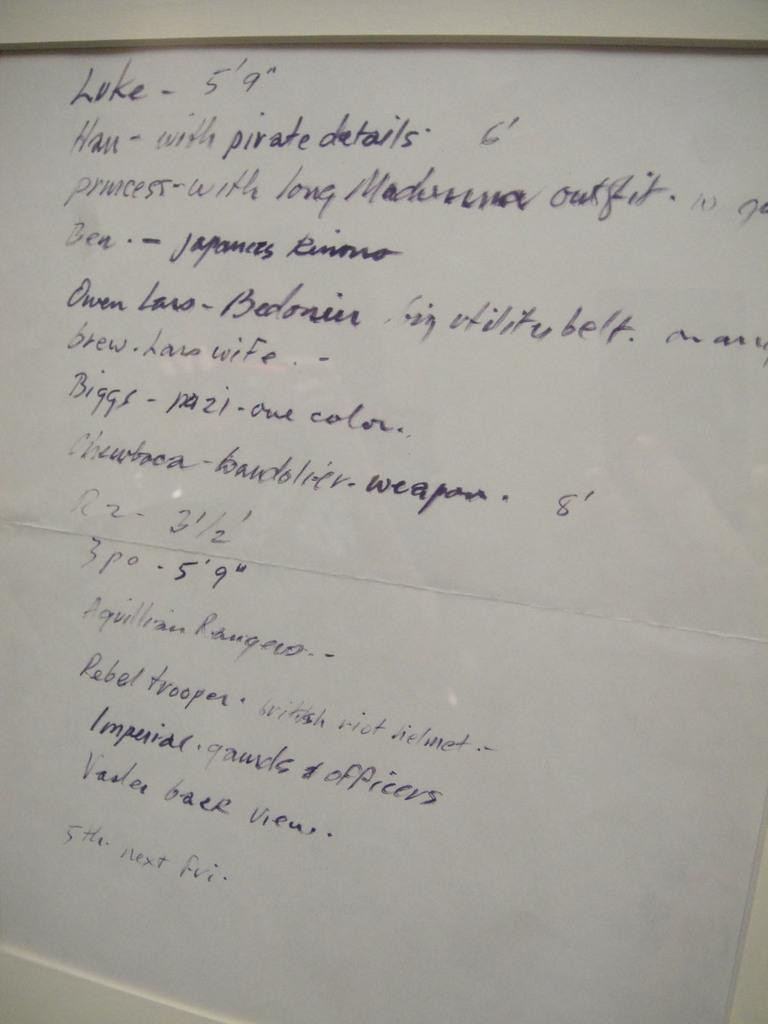<image>
Summarize the visual content of the image. "Luke - 5'9'" is written on the top of a white board. 